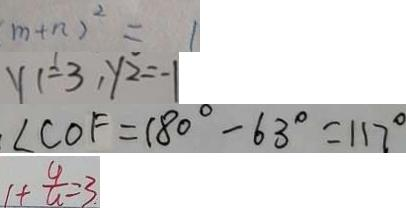<formula> <loc_0><loc_0><loc_500><loc_500>m + n ) ^ { 2 } = 1 
 y 1 = 3 , y _ { 2 } = - 1 
 . \angle C O F = 1 8 0 ^ { \circ } - 6 3 ^ { \circ } = 1 1 7 ^ { \circ } 
 1 + \frac { 4 } { u } = 3 .</formula> 